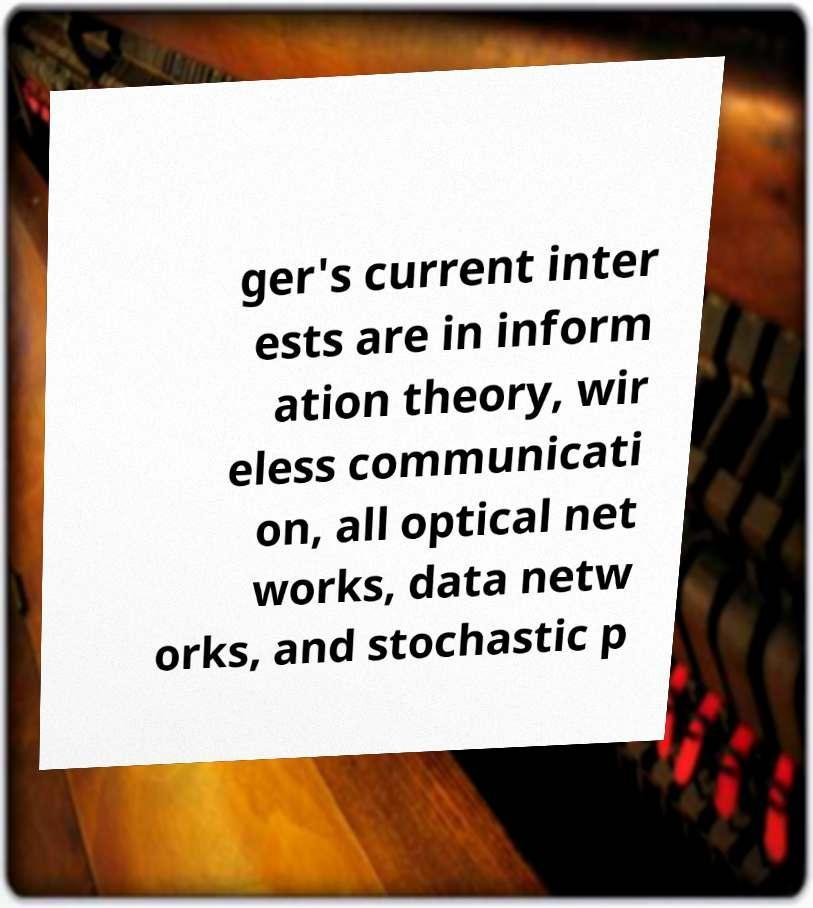I need the written content from this picture converted into text. Can you do that? ger's current inter ests are in inform ation theory, wir eless communicati on, all optical net works, data netw orks, and stochastic p 